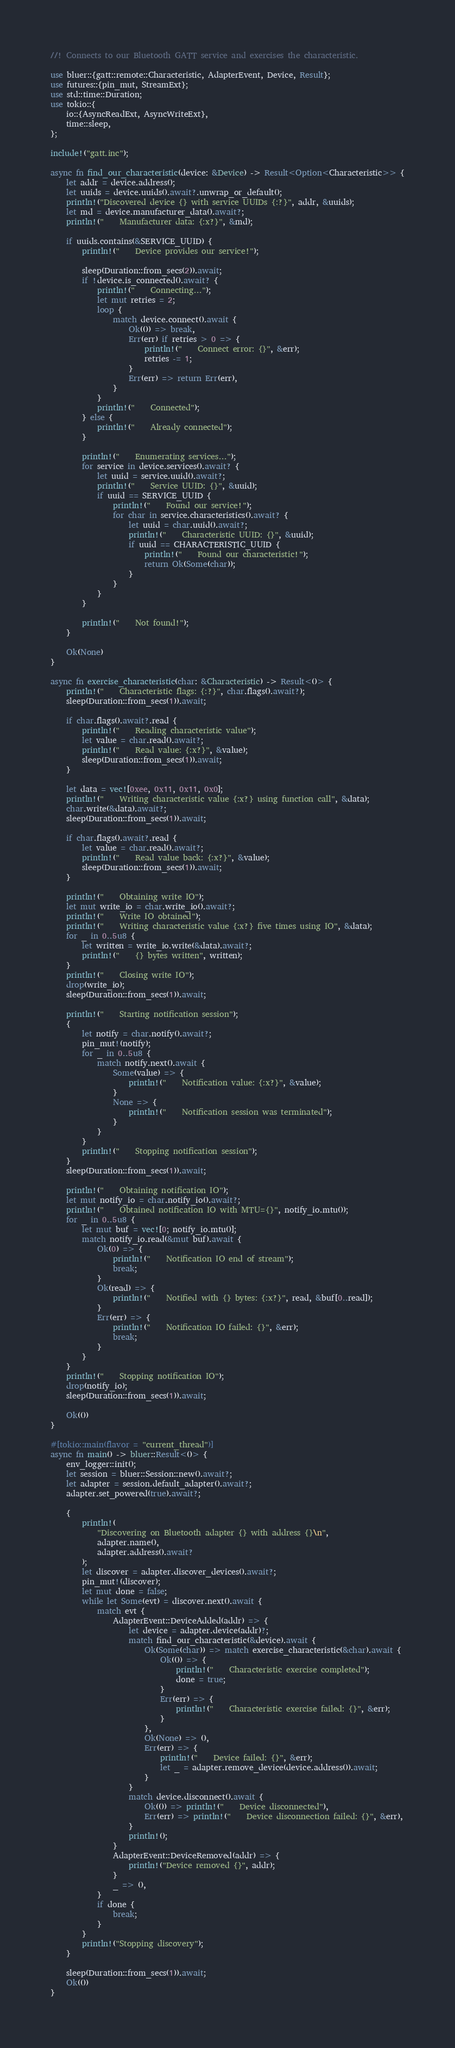<code> <loc_0><loc_0><loc_500><loc_500><_Rust_>//! Connects to our Bluetooth GATT service and exercises the characteristic.

use bluer::{gatt::remote::Characteristic, AdapterEvent, Device, Result};
use futures::{pin_mut, StreamExt};
use std::time::Duration;
use tokio::{
    io::{AsyncReadExt, AsyncWriteExt},
    time::sleep,
};

include!("gatt.inc");

async fn find_our_characteristic(device: &Device) -> Result<Option<Characteristic>> {
    let addr = device.address();
    let uuids = device.uuids().await?.unwrap_or_default();
    println!("Discovered device {} with service UUIDs {:?}", addr, &uuids);
    let md = device.manufacturer_data().await?;
    println!("    Manufacturer data: {:x?}", &md);

    if uuids.contains(&SERVICE_UUID) {
        println!("    Device provides our service!");

        sleep(Duration::from_secs(2)).await;
        if !device.is_connected().await? {
            println!("    Connecting...");
            let mut retries = 2;
            loop {
                match device.connect().await {
                    Ok(()) => break,
                    Err(err) if retries > 0 => {
                        println!("    Connect error: {}", &err);
                        retries -= 1;
                    }
                    Err(err) => return Err(err),
                }
            }
            println!("    Connected");
        } else {
            println!("    Already connected");
        }

        println!("    Enumerating services...");
        for service in device.services().await? {
            let uuid = service.uuid().await?;
            println!("    Service UUID: {}", &uuid);
            if uuid == SERVICE_UUID {
                println!("    Found our service!");
                for char in service.characteristics().await? {
                    let uuid = char.uuid().await?;
                    println!("    Characteristic UUID: {}", &uuid);
                    if uuid == CHARACTERISTIC_UUID {
                        println!("    Found our characteristic!");
                        return Ok(Some(char));
                    }
                }
            }
        }

        println!("    Not found!");
    }

    Ok(None)
}

async fn exercise_characteristic(char: &Characteristic) -> Result<()> {
    println!("    Characteristic flags: {:?}", char.flags().await?);
    sleep(Duration::from_secs(1)).await;

    if char.flags().await?.read {
        println!("    Reading characteristic value");
        let value = char.read().await?;
        println!("    Read value: {:x?}", &value);
        sleep(Duration::from_secs(1)).await;
    }

    let data = vec![0xee, 0x11, 0x11, 0x0];
    println!("    Writing characteristic value {:x?} using function call", &data);
    char.write(&data).await?;
    sleep(Duration::from_secs(1)).await;

    if char.flags().await?.read {
        let value = char.read().await?;
        println!("    Read value back: {:x?}", &value);
        sleep(Duration::from_secs(1)).await;
    }

    println!("    Obtaining write IO");
    let mut write_io = char.write_io().await?;
    println!("    Write IO obtained");
    println!("    Writing characteristic value {:x?} five times using IO", &data);
    for _ in 0..5u8 {
        let written = write_io.write(&data).await?;
        println!("    {} bytes written", written);
    }
    println!("    Closing write IO");
    drop(write_io);
    sleep(Duration::from_secs(1)).await;

    println!("    Starting notification session");
    {
        let notify = char.notify().await?;
        pin_mut!(notify);
        for _ in 0..5u8 {
            match notify.next().await {
                Some(value) => {
                    println!("    Notification value: {:x?}", &value);
                }
                None => {
                    println!("    Notification session was terminated");
                }
            }
        }
        println!("    Stopping notification session");
    }
    sleep(Duration::from_secs(1)).await;

    println!("    Obtaining notification IO");
    let mut notify_io = char.notify_io().await?;
    println!("    Obtained notification IO with MTU={}", notify_io.mtu());
    for _ in 0..5u8 {
        let mut buf = vec![0; notify_io.mtu()];
        match notify_io.read(&mut buf).await {
            Ok(0) => {
                println!("    Notification IO end of stream");
                break;
            }
            Ok(read) => {
                println!("    Notified with {} bytes: {:x?}", read, &buf[0..read]);
            }
            Err(err) => {
                println!("    Notification IO failed: {}", &err);
                break;
            }
        }
    }
    println!("    Stopping notification IO");
    drop(notify_io);
    sleep(Duration::from_secs(1)).await;

    Ok(())
}

#[tokio::main(flavor = "current_thread")]
async fn main() -> bluer::Result<()> {
    env_logger::init();
    let session = bluer::Session::new().await?;
    let adapter = session.default_adapter().await?;
    adapter.set_powered(true).await?;

    {
        println!(
            "Discovering on Bluetooth adapter {} with address {}\n",
            adapter.name(),
            adapter.address().await?
        );
        let discover = adapter.discover_devices().await?;
        pin_mut!(discover);
        let mut done = false;
        while let Some(evt) = discover.next().await {
            match evt {
                AdapterEvent::DeviceAdded(addr) => {
                    let device = adapter.device(addr)?;
                    match find_our_characteristic(&device).await {
                        Ok(Some(char)) => match exercise_characteristic(&char).await {
                            Ok(()) => {
                                println!("    Characteristic exercise completed");
                                done = true;
                            }
                            Err(err) => {
                                println!("    Characteristic exercise failed: {}", &err);
                            }
                        },
                        Ok(None) => (),
                        Err(err) => {
                            println!("    Device failed: {}", &err);
                            let _ = adapter.remove_device(device.address()).await;
                        }
                    }
                    match device.disconnect().await {
                        Ok(()) => println!("    Device disconnected"),
                        Err(err) => println!("    Device disconnection failed: {}", &err),
                    }
                    println!();
                }
                AdapterEvent::DeviceRemoved(addr) => {
                    println!("Device removed {}", addr);
                }
                _ => (),
            }
            if done {
                break;
            }
        }
        println!("Stopping discovery");
    }

    sleep(Duration::from_secs(1)).await;
    Ok(())
}
</code> 